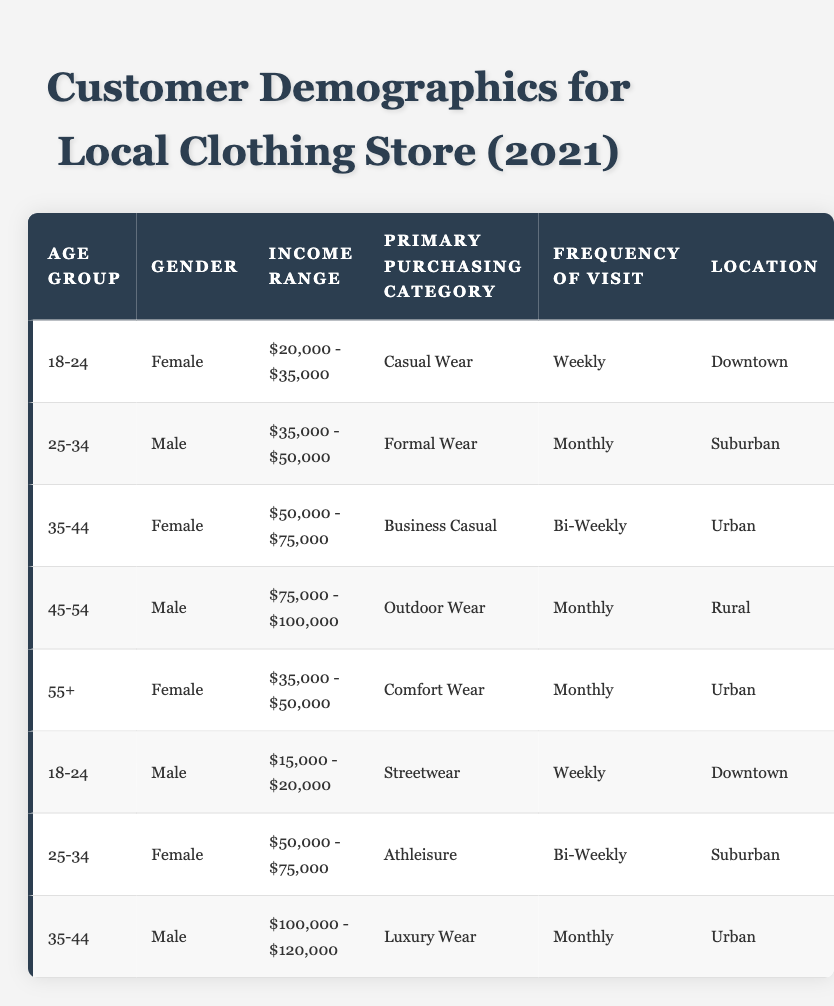What is the primary purchasing category for customers aged 18-24? There are two entries for the age group 18-24 in the table: one for a female customer who purchases Casual Wear and one for a male customer who purchases Streetwear. Since the question asks for the primary purchasing category, we can say that both categories are relevant.
Answer: Casual Wear and Streetwear Which income range is most common among female customers? In the table, female customers appear in three different income ranges: $20,000 - $35,000, $50,000 - $75,000, and $35,000 - $50,000. The income ranges of $20,000 - $35,000 and $35,000 - $50,000 each appear once, while $50,000 - $75,000 appears once. Thus, there is no most common range; all ranges are equally common among female customers.
Answer: No most common range How many male customers visit the store weekly? The table has two male customers who visit weekly: one in the 18-24 age group and another is not specified. Adding them up gives a total of one customer in the specified frequency (weekly).
Answer: 1 What is the frequency of visits for customers in the income range of $35,000 - $50,000? There are two customers in this income range: a female customer in the age group 55+ who visits monthly, and a male customer aged 25-34 who visits monthly as well. Both customers visit monthly in the specified income range.
Answer: Monthly What is the average income range of customers aged 35-44? The income ranges for the two customers in the 35-44 age group are $50,000 - $75,000 and $100,000 - $120,000. To find the average, we note the midpoints (i.e., $57,500 and $110,000) and sum them: ($57,500 + $110,000) / 2 = $83,750. Therefore, the average income range is around $83,750.
Answer: $83,750 Are customers who live in the Urban location more likely to purchase Business Casual than Luxury Wear? There are two customers in the Urban area: one male customer purchasing Luxury Wear and one female customer purchasing Business Casual. Since the count of Business Casual is 1 and Luxury Wear is 1, the likelihood is equal in this case.
Answer: No What is the most frequent purchasing category for customers living in Downtown? There are two customers from Downtown: one female purchasing Casual Wear and one male purchasing Streetwear. Both categories are represented, making it impossible to select a single category as the most frequent.
Answer: Casual Wear and Streetwear What percentage of all customers are male? There are a total of 8 customers, out of which 4 are male. To find the percentage, we calculate (4 males / 8 total customers) * 100 = 50%.
Answer: 50% How many customers visit the store monthly and what is their average age group? There are two customers who visit monthly: one in the age group 25-34 (male) and another in 45-54 (male). To find the average age group, we consider (25 + 45) / 2 = 35. Therefore, the average age group is 35.
Answer: 35 What is the most common location among customers aged 25-34? There are two customers aged 25-34: one male in the suburban area and one female in the same income range. Both them reside in the Suburban area, indicating it is the most common location for that age group.
Answer: Suburban 